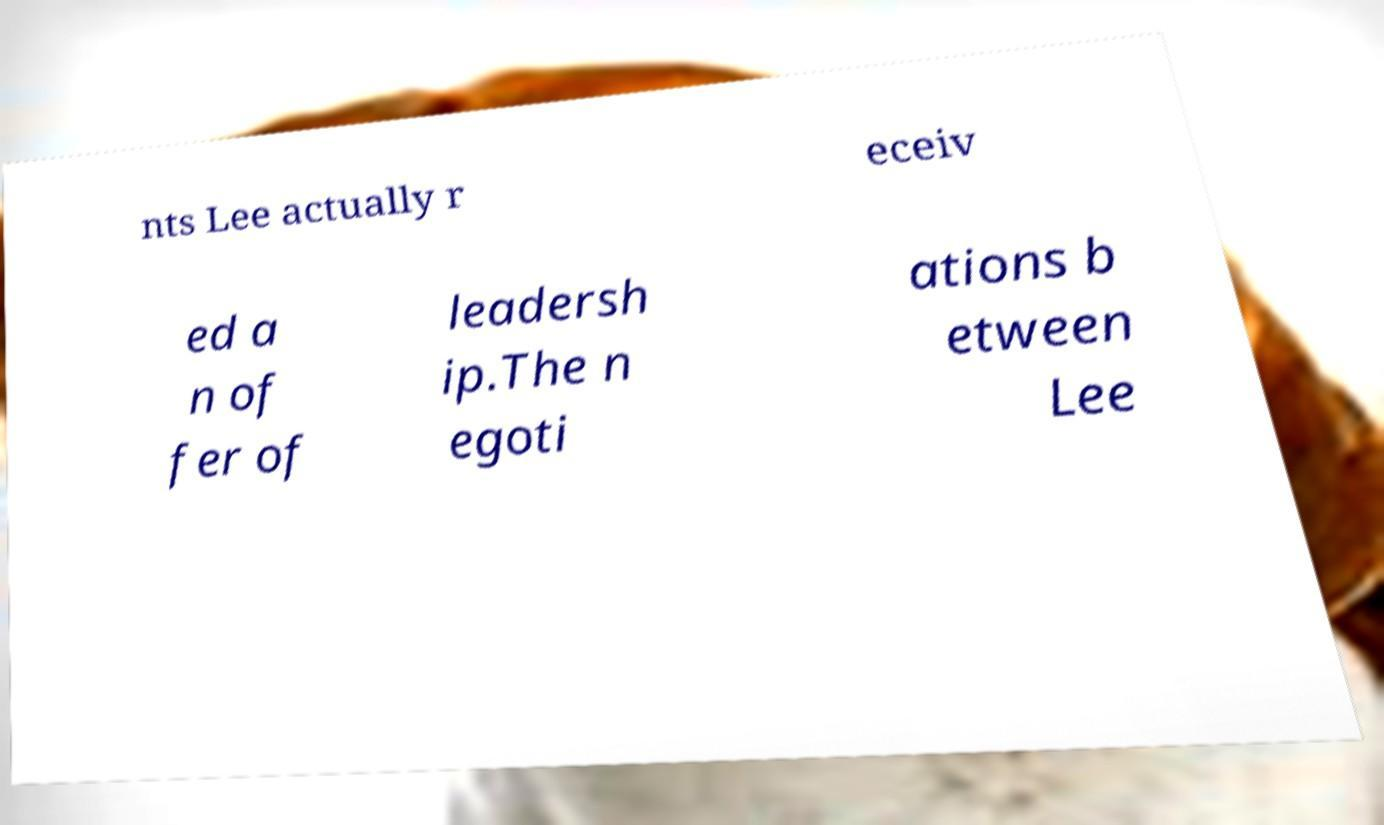Can you accurately transcribe the text from the provided image for me? nts Lee actually r eceiv ed a n of fer of leadersh ip.The n egoti ations b etween Lee 